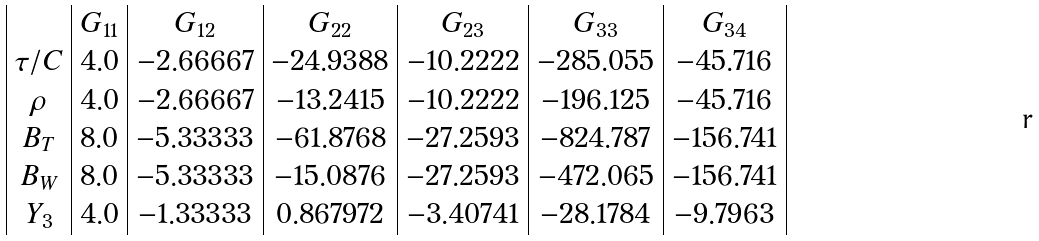Convert formula to latex. <formula><loc_0><loc_0><loc_500><loc_500>\begin{array} { | c | c | c | c | c | c | c | } & G _ { 1 1 } & G _ { 1 2 } & G _ { 2 2 } & G _ { 2 3 } & G _ { 3 3 } & G _ { 3 4 } \\ \tau / C & 4 . 0 & - 2 . 6 6 6 6 7 & - 2 4 . 9 3 8 8 & - 1 0 . 2 2 2 2 & - 2 8 5 . 0 5 5 & - 4 5 . 7 1 6 \\ \rho & 4 . 0 & - 2 . 6 6 6 6 7 & - 1 3 . 2 4 1 5 & - 1 0 . 2 2 2 2 & - 1 9 6 . 1 2 5 & - 4 5 . 7 1 6 \\ B _ { T } & 8 . 0 & - 5 . 3 3 3 3 3 & - 6 1 . 8 7 6 8 & - 2 7 . 2 5 9 3 & - 8 2 4 . 7 8 7 & - 1 5 6 . 7 4 1 \\ B _ { W } & 8 . 0 & - 5 . 3 3 3 3 3 & - 1 5 . 0 8 7 6 & - 2 7 . 2 5 9 3 & - 4 7 2 . 0 6 5 & - 1 5 6 . 7 4 1 \\ Y _ { 3 } & 4 . 0 & - 1 . 3 3 3 3 3 & 0 . 8 6 7 9 7 2 & - 3 . 4 0 7 4 1 & - 2 8 . 1 7 8 4 & - 9 . 7 9 6 3 \\ \end{array}</formula> 